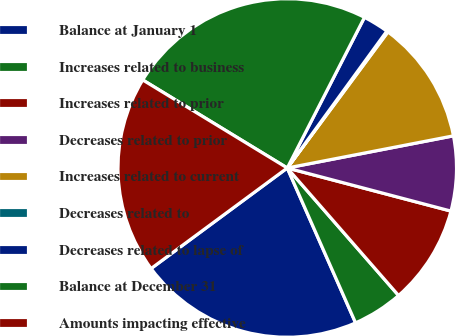Convert chart. <chart><loc_0><loc_0><loc_500><loc_500><pie_chart><fcel>Balance at January 1<fcel>Increases related to business<fcel>Increases related to prior<fcel>Decreases related to prior<fcel>Increases related to current<fcel>Decreases related to<fcel>Decreases related to lapse of<fcel>Balance at December 31<fcel>Amounts impacting effective<nl><fcel>21.49%<fcel>4.81%<fcel>9.48%<fcel>7.14%<fcel>11.82%<fcel>0.13%<fcel>2.47%<fcel>23.83%<fcel>18.83%<nl></chart> 